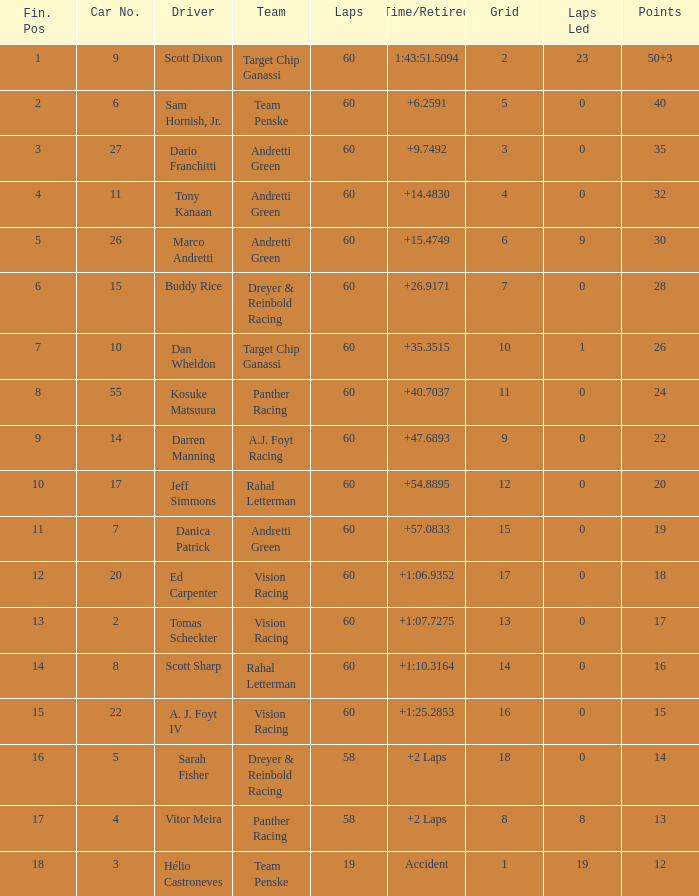What are the laps that result in 18 points? 60.0. 